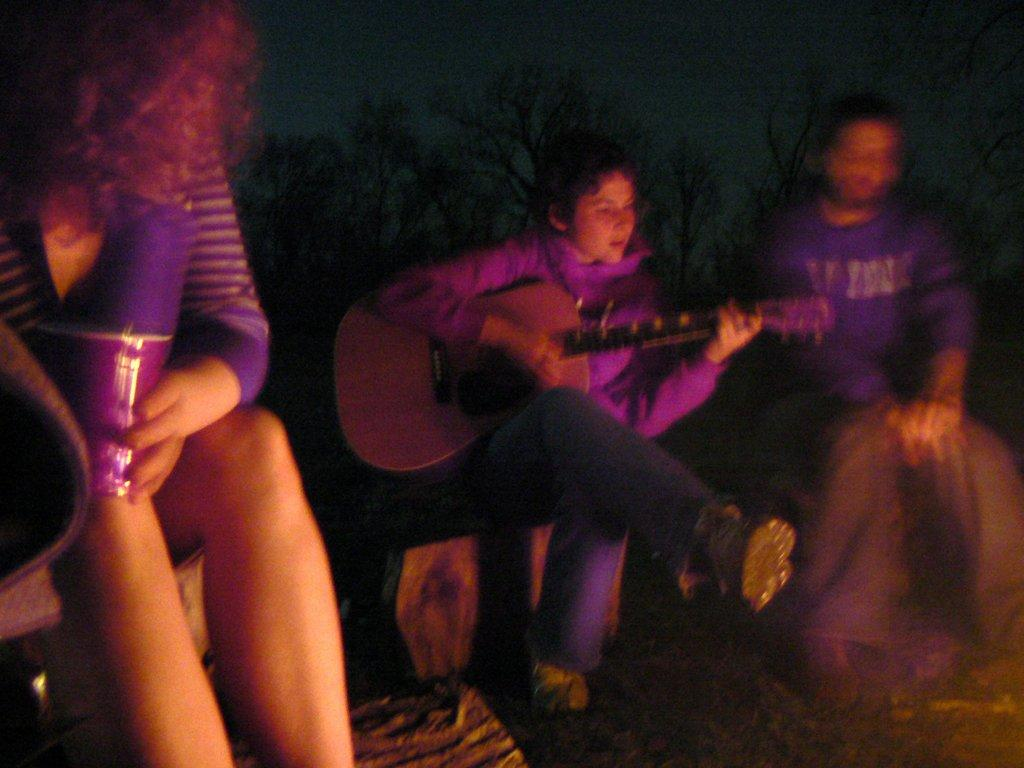How many people are in the image? There are three people in the image. What is the person in the center doing? The person in the center is playing a guitar. What can be seen in the background of the image? There are trees visible in the background of the image. What type of tub is visible in the image? There is no tub present in the image. What brass instrument is being played by the person in the center? The person in the center is playing a guitar, which is a stringed instrument, not a brass instrument. 